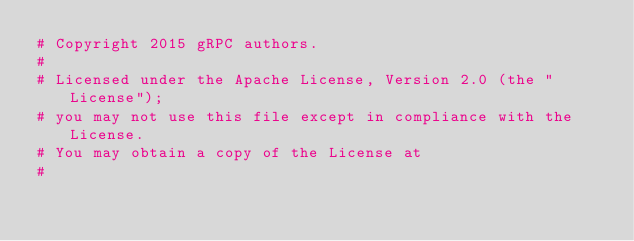<code> <loc_0><loc_0><loc_500><loc_500><_Dockerfile_># Copyright 2015 gRPC authors.
#
# Licensed under the Apache License, Version 2.0 (the "License");
# you may not use this file except in compliance with the License.
# You may obtain a copy of the License at
#</code> 